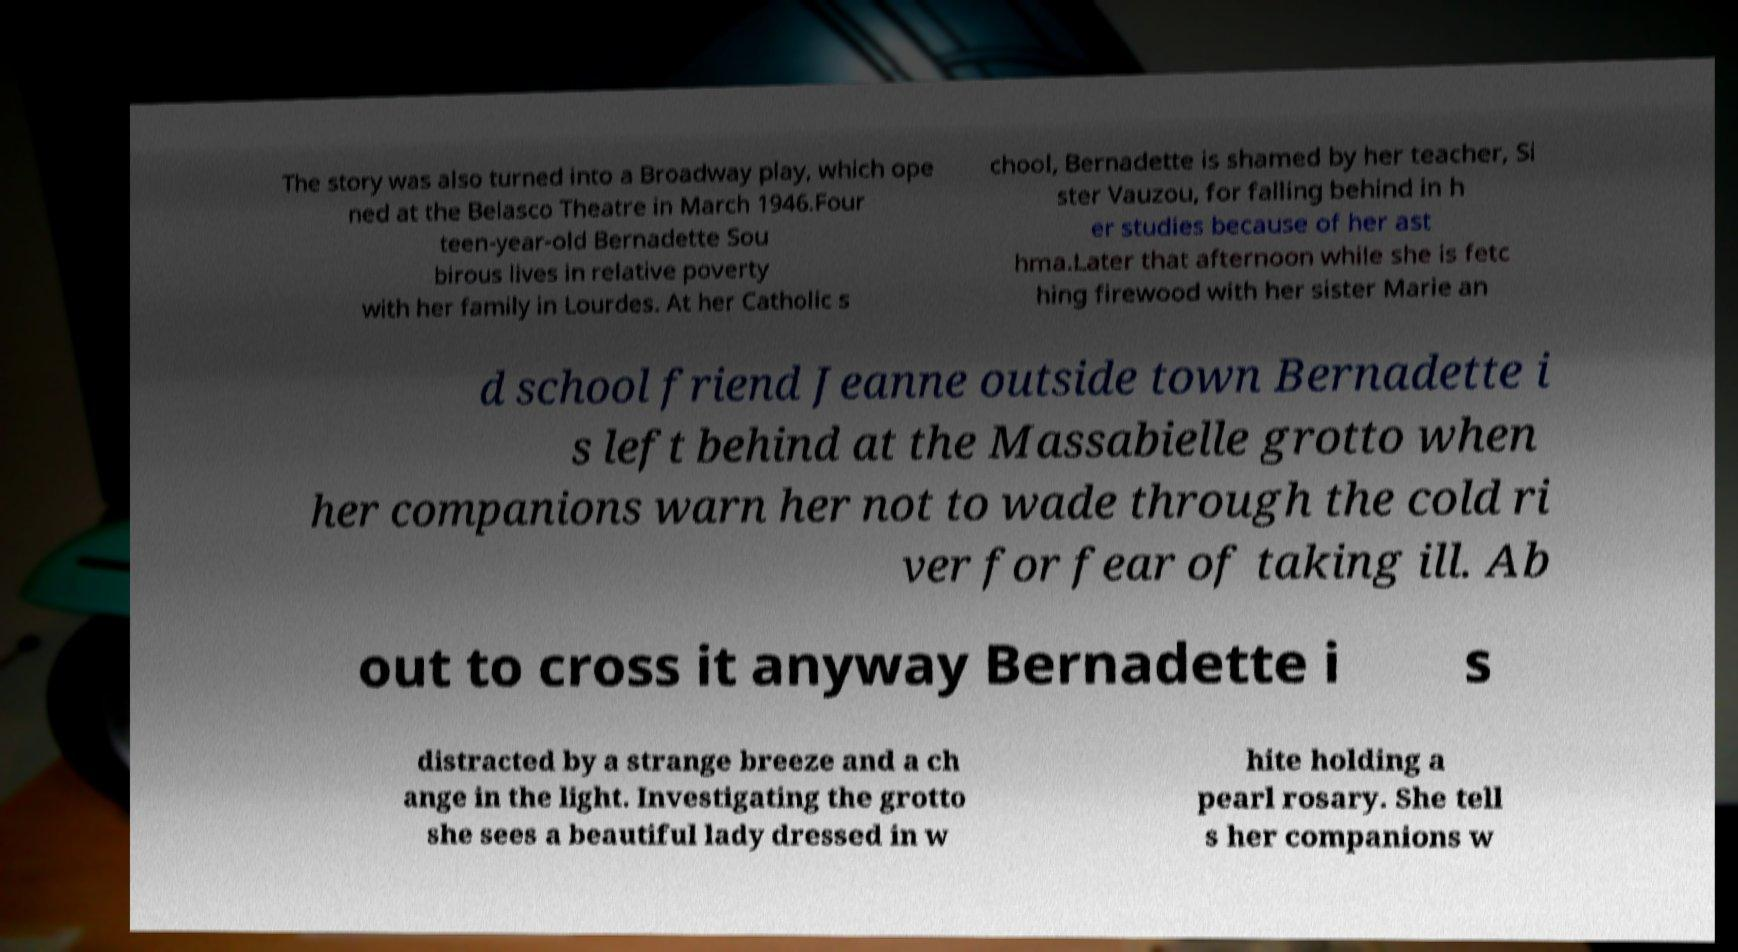What messages or text are displayed in this image? I need them in a readable, typed format. The story was also turned into a Broadway play, which ope ned at the Belasco Theatre in March 1946.Four teen-year-old Bernadette Sou birous lives in relative poverty with her family in Lourdes. At her Catholic s chool, Bernadette is shamed by her teacher, Si ster Vauzou, for falling behind in h er studies because of her ast hma.Later that afternoon while she is fetc hing firewood with her sister Marie an d school friend Jeanne outside town Bernadette i s left behind at the Massabielle grotto when her companions warn her not to wade through the cold ri ver for fear of taking ill. Ab out to cross it anyway Bernadette i s distracted by a strange breeze and a ch ange in the light. Investigating the grotto she sees a beautiful lady dressed in w hite holding a pearl rosary. She tell s her companions w 